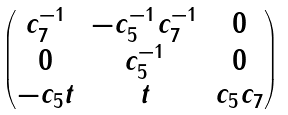<formula> <loc_0><loc_0><loc_500><loc_500>\begin{pmatrix} c _ { 7 } ^ { - 1 } & - c _ { 5 } ^ { - 1 } c _ { 7 } ^ { - 1 } & 0 \\ 0 & c _ { 5 } ^ { - 1 } & 0 \\ - c _ { 5 } t & t & c _ { 5 } c _ { 7 } \end{pmatrix}</formula> 